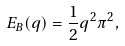<formula> <loc_0><loc_0><loc_500><loc_500>E _ { B } ( q ) = \frac { 1 } { 2 } q ^ { 2 } \pi ^ { 2 } ,</formula> 